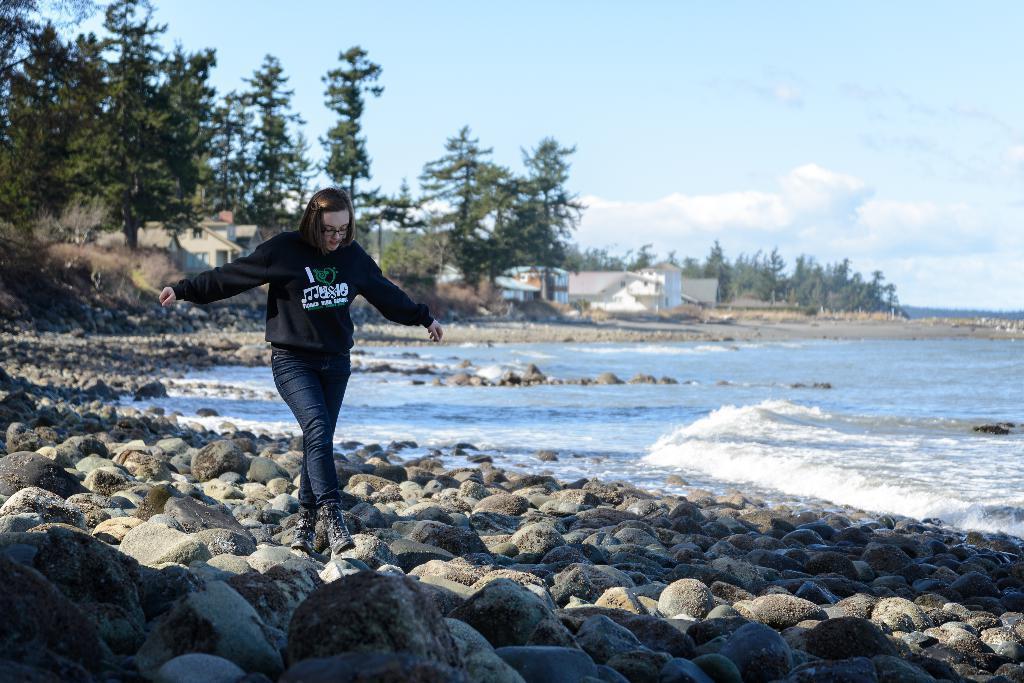In one or two sentences, can you explain what this image depicts? There is one woman walking on the stones as we can see at the bottom of this image. There is a surface of water on the right side of this image, and there are some trees and houses in the background, and there is a cloudy sky at the top of this image. 